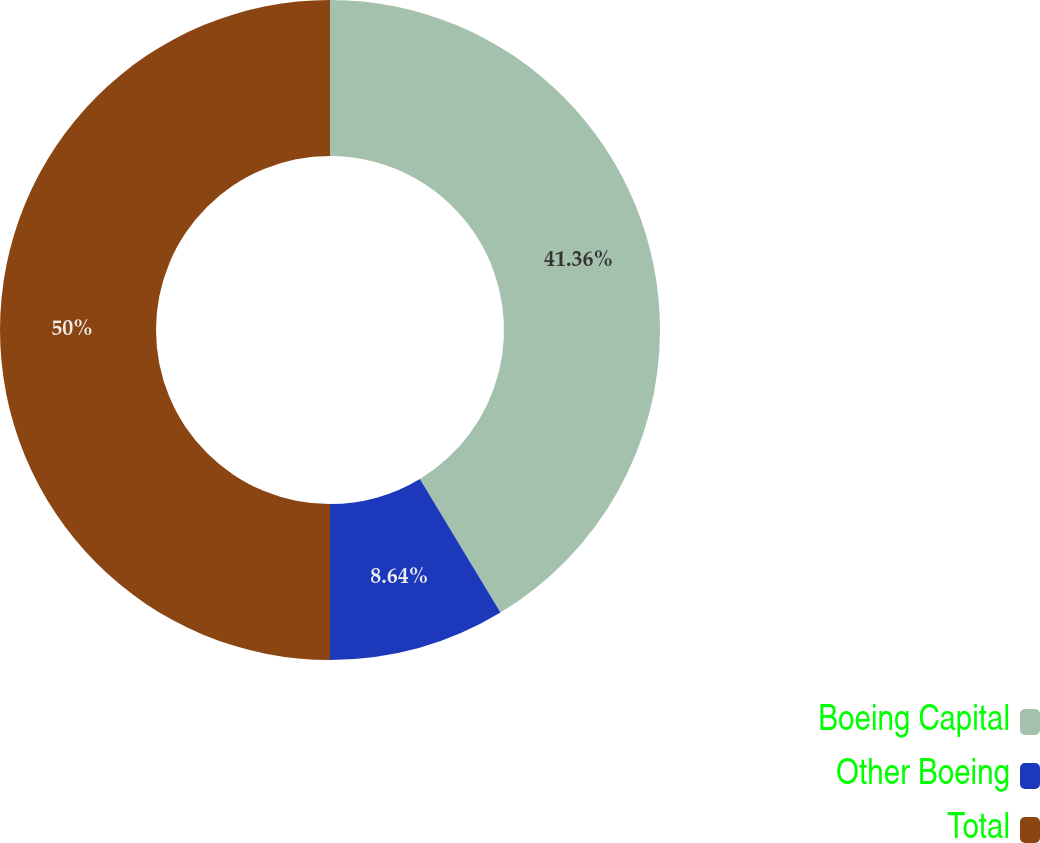<chart> <loc_0><loc_0><loc_500><loc_500><pie_chart><fcel>Boeing Capital<fcel>Other Boeing<fcel>Total<nl><fcel>41.36%<fcel>8.64%<fcel>50.0%<nl></chart> 